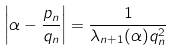<formula> <loc_0><loc_0><loc_500><loc_500>\left | \alpha - \frac { p _ { n } } { q _ { n } } \right | = \frac { 1 } { \lambda _ { n + 1 } ( \alpha ) q _ { n } ^ { 2 } }</formula> 